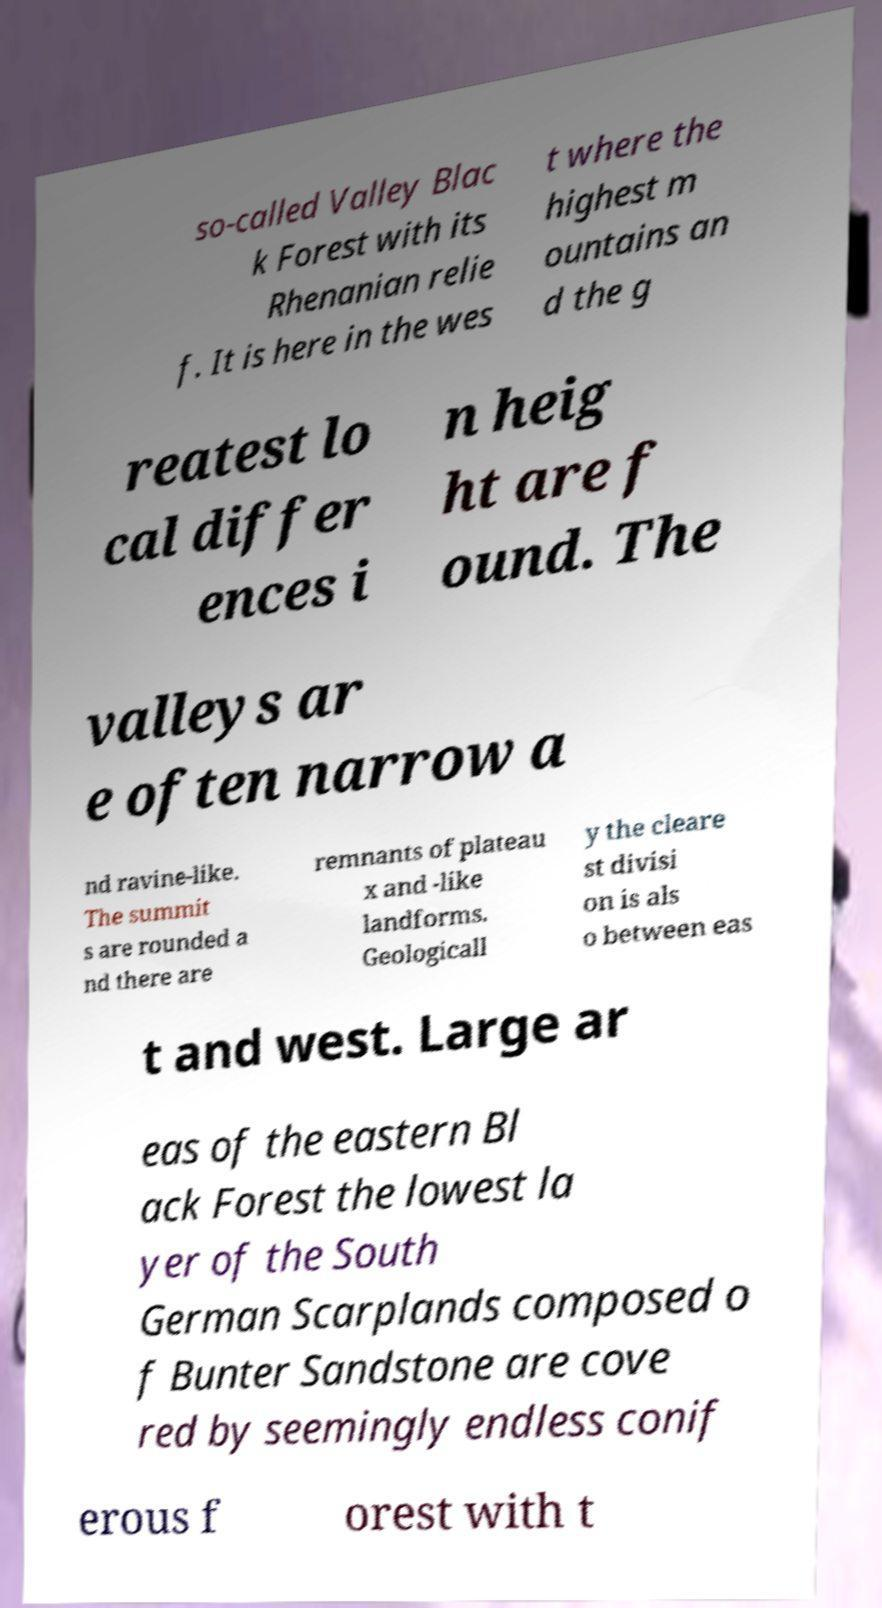Could you extract and type out the text from this image? so-called Valley Blac k Forest with its Rhenanian relie f. It is here in the wes t where the highest m ountains an d the g reatest lo cal differ ences i n heig ht are f ound. The valleys ar e often narrow a nd ravine-like. The summit s are rounded a nd there are remnants of plateau x and -like landforms. Geologicall y the cleare st divisi on is als o between eas t and west. Large ar eas of the eastern Bl ack Forest the lowest la yer of the South German Scarplands composed o f Bunter Sandstone are cove red by seemingly endless conif erous f orest with t 